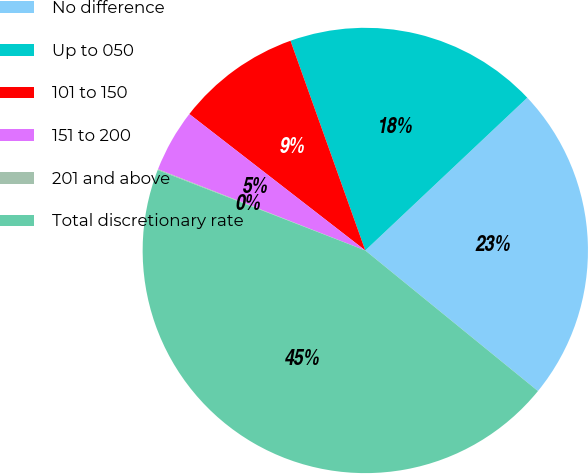Convert chart to OTSL. <chart><loc_0><loc_0><loc_500><loc_500><pie_chart><fcel>No difference<fcel>Up to 050<fcel>101 to 150<fcel>151 to 200<fcel>201 and above<fcel>Total discretionary rate<nl><fcel>22.91%<fcel>18.42%<fcel>9.05%<fcel>4.55%<fcel>0.06%<fcel>45.01%<nl></chart> 